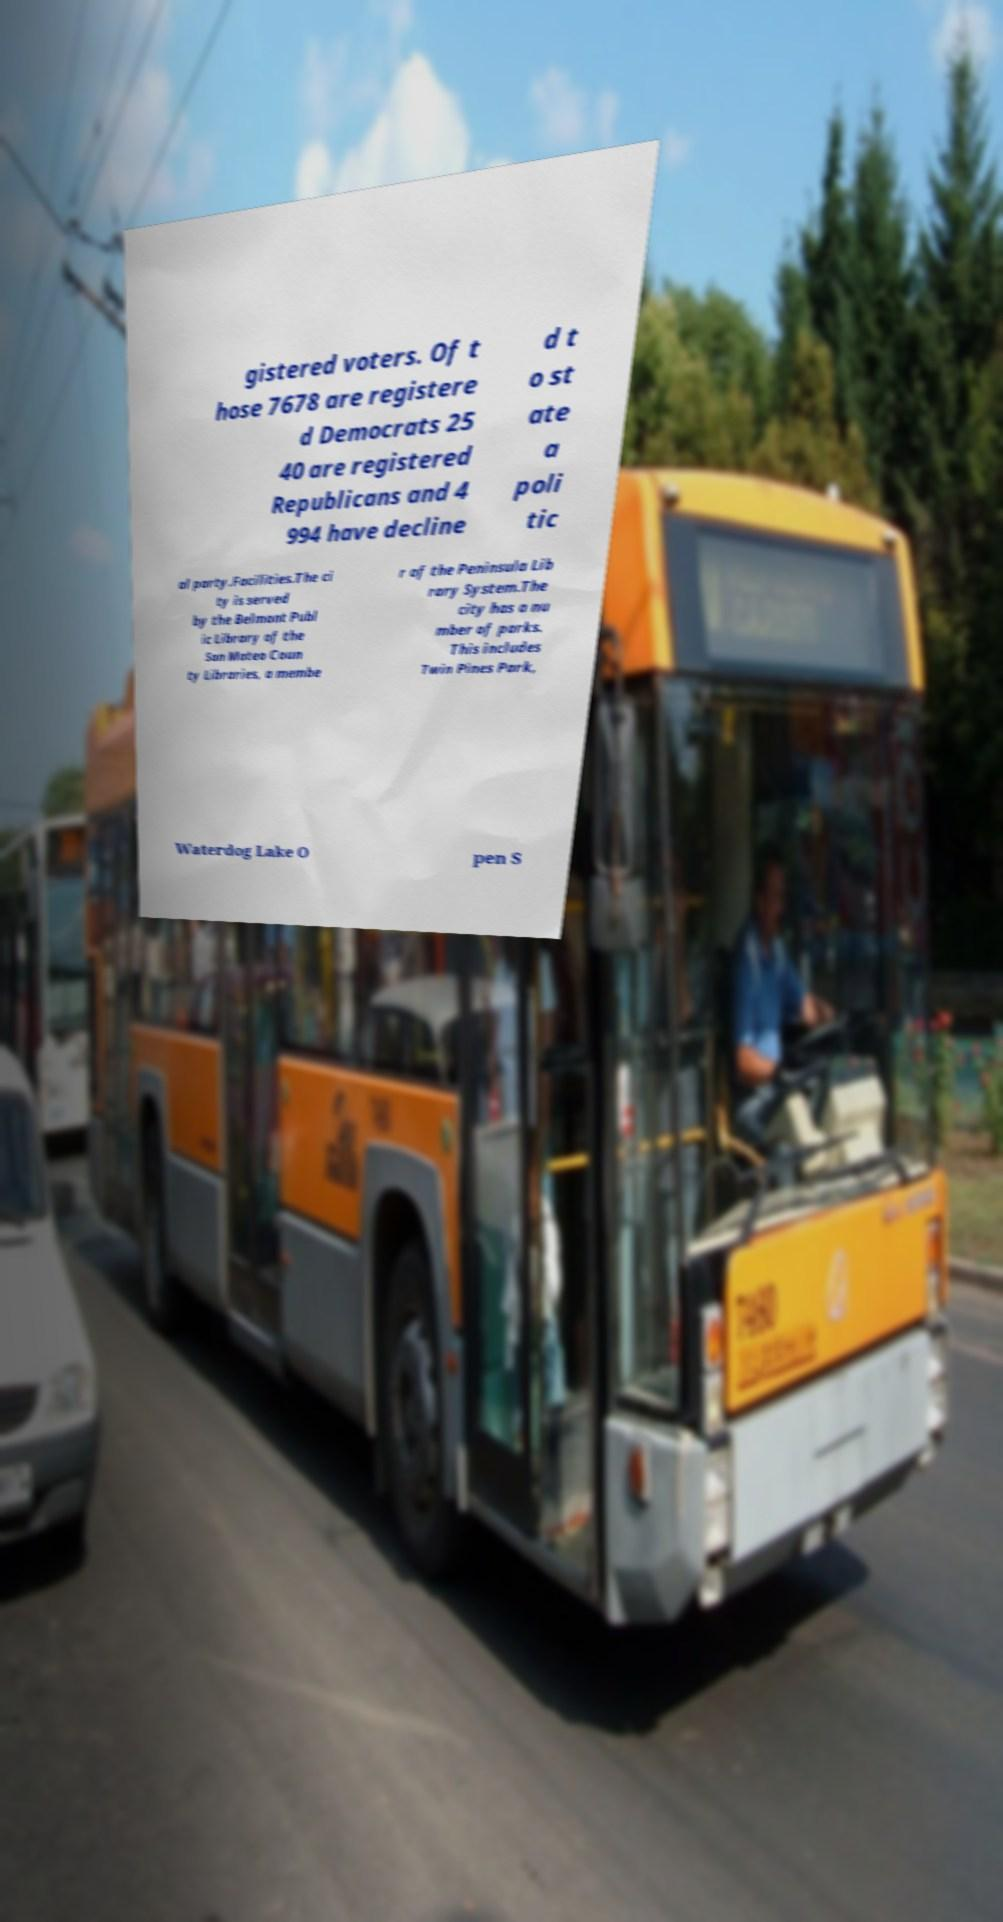For documentation purposes, I need the text within this image transcribed. Could you provide that? gistered voters. Of t hose 7678 are registere d Democrats 25 40 are registered Republicans and 4 994 have decline d t o st ate a poli tic al party.Facilities.The ci ty is served by the Belmont Publ ic Library of the San Mateo Coun ty Libraries, a membe r of the Peninsula Lib rary System.The city has a nu mber of parks. This includes Twin Pines Park, Waterdog Lake O pen S 